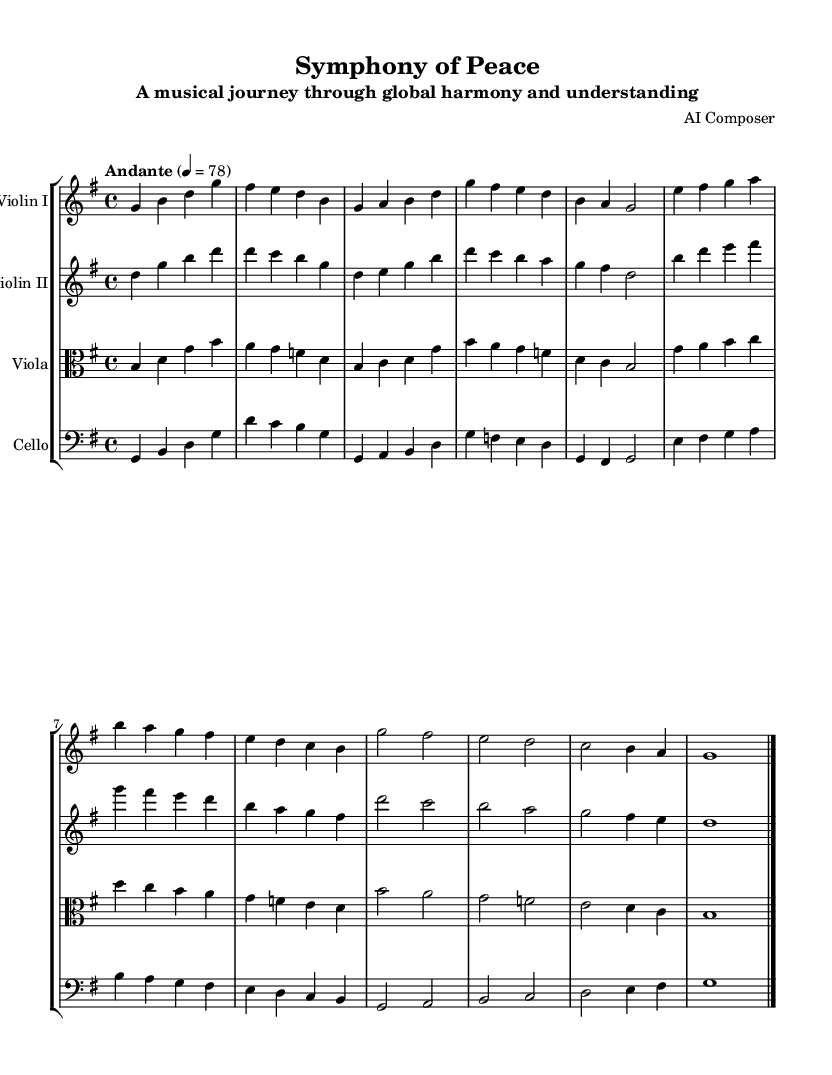What is the key signature of this music? The key signature indicates the key of G major, which has one sharp (F#) and is represented at the beginning of the staff.
Answer: G major What is the time signature of this music? The time signature is found at the beginning of the score, indicating that each measure has four beats, which is represented as 4/4.
Answer: 4/4 What is the tempo marking for this composition? The tempo marking is indicated by the word "Andante" above the score, which suggests a moderate pace, and the number 4 equals 78 specifies the beats per minute.
Answer: Andante How many measures are there in the first violin part? By counting the distinct groupings of notes separated by the vertical bar lines, we find there are 8 measures in total for the first violin.
Answer: 8 Which instruments are included in this symphony? The instruments listed above each staff, which include Violin I, Violin II, Viola, and Cello, provide the information on the ensemble.
Answer: Violin I, Violin II, Viola, Cello What is the last note of the cello part? Looking at the final note in the cello section, we can see it ends on G, which is indicated in the final measure of the page.
Answer: G What is the dynamic marking that could be inferred from this symphony's title? The title "Symphony of Peace" suggests a calm and tranquil dynamic, which often translates into a quiet and soothing performance, though no specific dynamic markings appear in the score.
Answer: Calm 